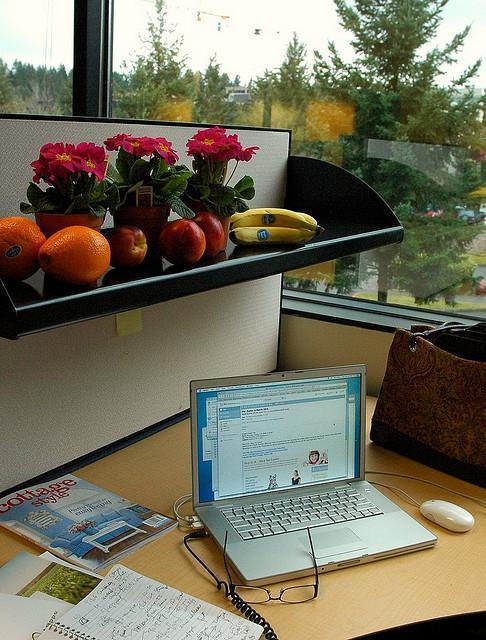How many open laptops?
Give a very brief answer. 1. How many potted plants can you see?
Give a very brief answer. 3. How many books are in the picture?
Give a very brief answer. 2. How many oranges are there?
Give a very brief answer. 2. How many handbags are in the picture?
Give a very brief answer. 1. How many doors does the red car have?
Give a very brief answer. 0. 